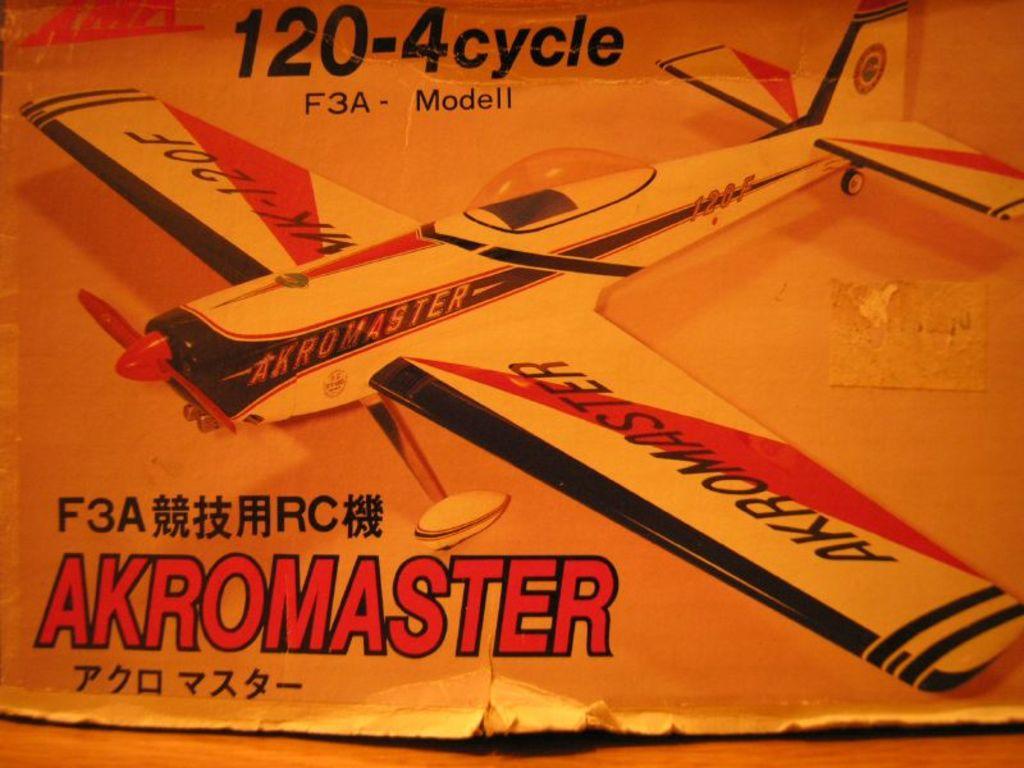What is the number at the top of the box?
Provide a succinct answer. 120-4. 